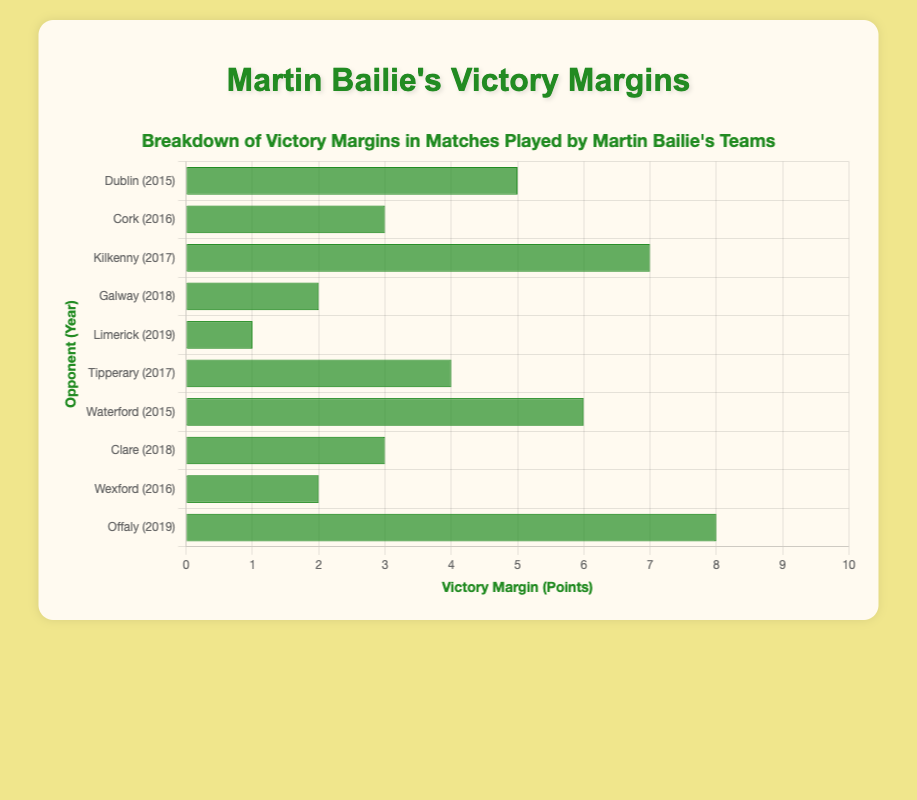What is the highest victory margin achieved by Martin Bailie's teams? To find the highest victory margin, we look for the largest bar in the chart. The bar representing the match against Offaly in 2019 has the highest victory margin of 8 points.
Answer: 8 Which opponent saw the smallest victory margin by Martin Bailie's teams? To determine the smallest victory margin, we identify the shortest bar in the chart. The match against Limerick in 2019 had the smallest victory margin of 1 point.
Answer: Limerick What is the total sum of victory margins in matches played by Martin Bailie's teams? Add up all victory margins from each match: 5 (Dublin) + 3 (Cork) + 7 (Kilkenny) + 2 (Galway) + 1 (Limerick) + 4 (Tipperary) + 6 (Waterford) + 3 (Clare) + 2 (Wexford) + 8 (Offaly) = 41 points.
Answer: 41 How many matches had a victory margin of 5 points or more? Count the bars whose lengths represent victory margins of 5 points or greater: Dublin (5), Kilkenny (7), Waterford (6), and Offaly (8). So, there are 4 such matches.
Answer: 4 Which opponent had a victory margin closest to 4 points? Compare the bars to find the one closest to 4 points. Tipperary in 2017 had a victory margin of exactly 4 points.
Answer: Tipperary What is the difference in victory margins between the match against Kilkenny and the match against Wexford? The victory margin against Kilkenny is 7 points, and against Wexford, it is 2 points. The difference is 7 - 2 = 5 points.
Answer: 5 What is the average victory margin across all matches played by Martin Bailie's teams? Sum all the victory margins and divide by the number of matches: (5 + 3 + 7 + 2 + 1 + 4 + 6 + 3 + 2 + 8) / 10 = 41 / 10 = 4.1 points.
Answer: 4.1 How many matches had victory margins between 2 and 5 points inclusive? Identify and count the matches with victory margins from 2 to 5 points: Cork (3), Galway (2), Tipperary (4), Clare (3), and Wexford (2). So, there are 5 such matches.
Answer: 5 